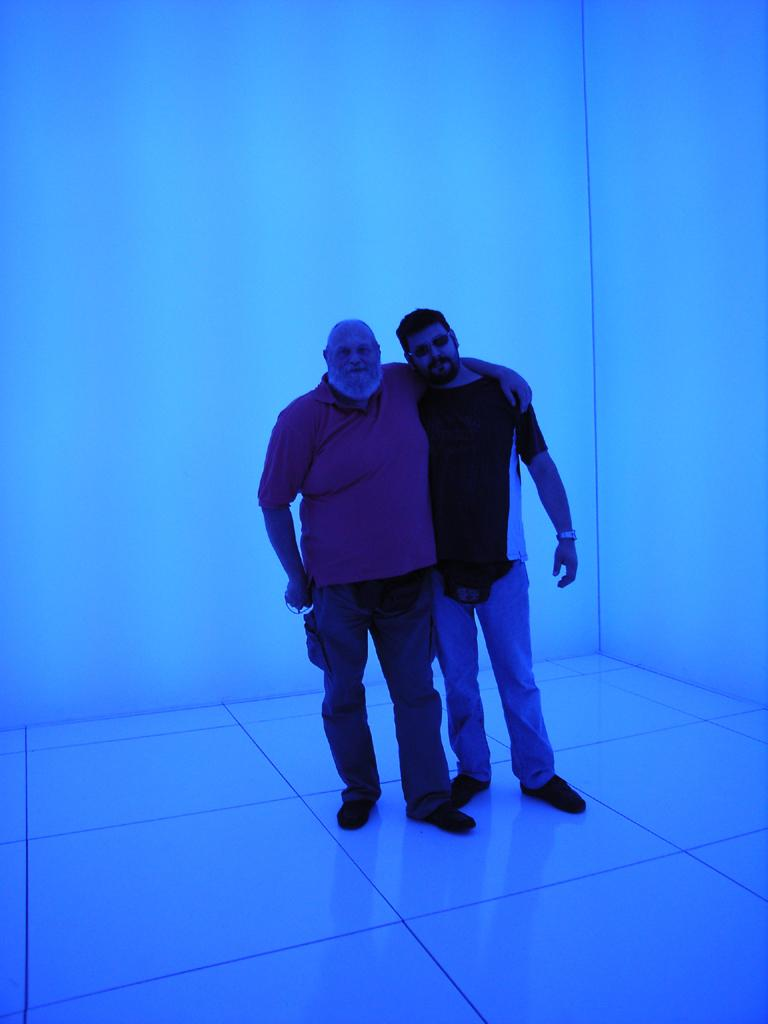How many people are in the image? There are two men standing in the image. What is the surface they are standing on? The men are standing on the floor. What can be seen in the background of the image? There is a wall in the background of the image. What type of pleasure can be seen in the rhythm of the minister's speech in the image? There is no minister or speech present in the image; it features two men standing on the floor with a wall in the background. 